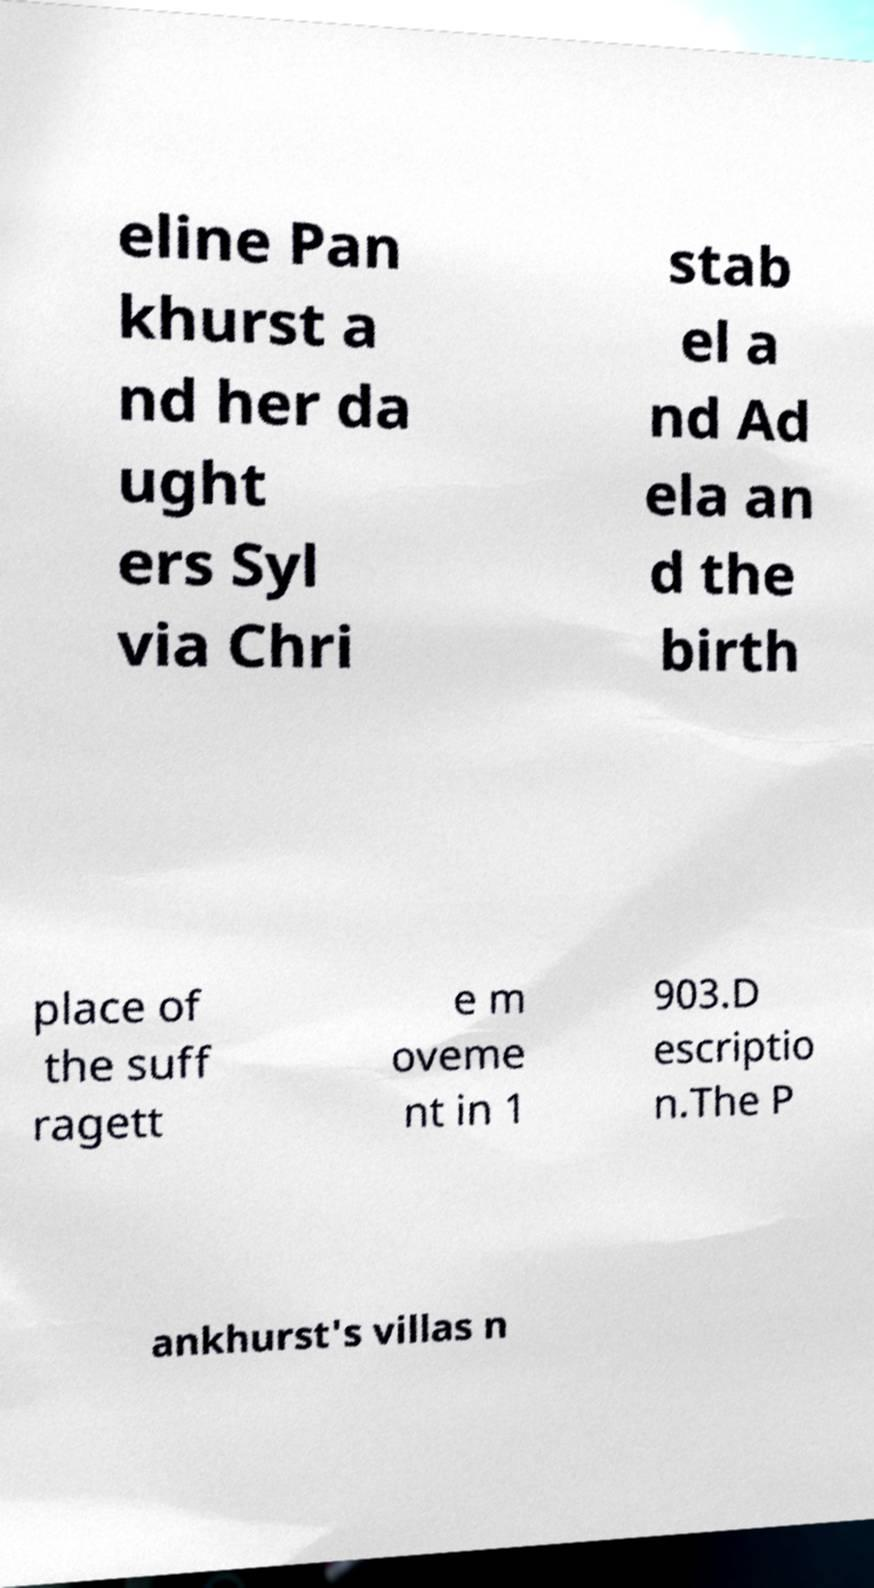Please identify and transcribe the text found in this image. eline Pan khurst a nd her da ught ers Syl via Chri stab el a nd Ad ela an d the birth place of the suff ragett e m oveme nt in 1 903.D escriptio n.The P ankhurst's villas n 